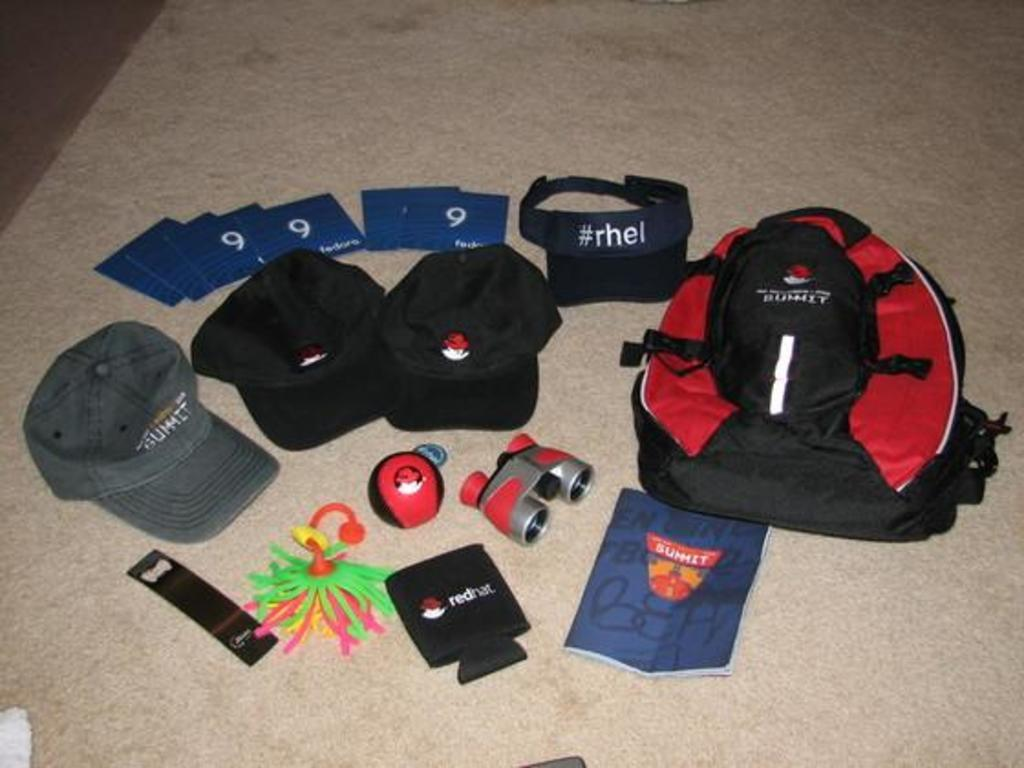What object is on the floor in the image? There is a bag on the floor. What else can be seen on the floor in the image? There is a cap, a paper, a ball, and cards on the floor. What type of leather material can be seen in the image? There is no leather material present in the image. How is the steam being used in the image? There is no steam present in the image. What is the hammer being used for in the image? There is no hammer present in the image. 